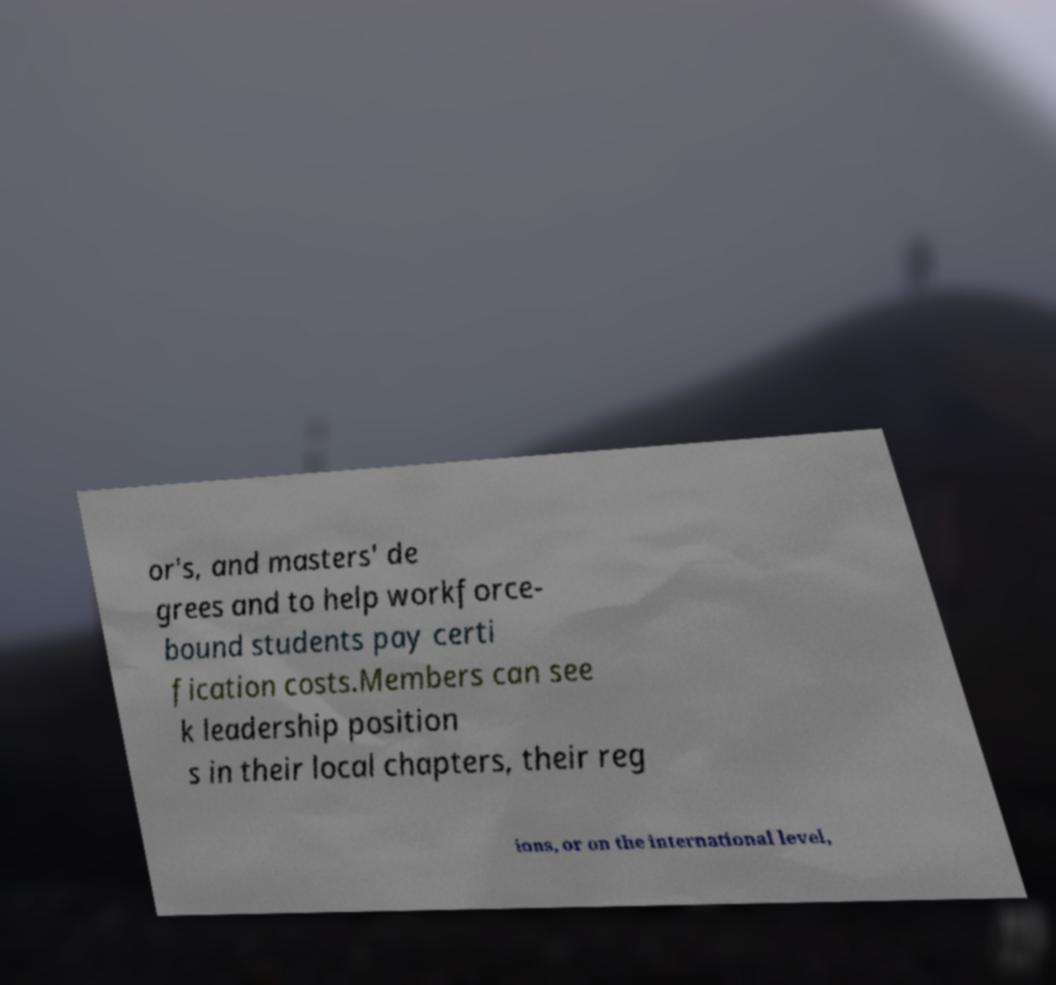For documentation purposes, I need the text within this image transcribed. Could you provide that? or's, and masters' de grees and to help workforce- bound students pay certi fication costs.Members can see k leadership position s in their local chapters, their reg ions, or on the international level, 